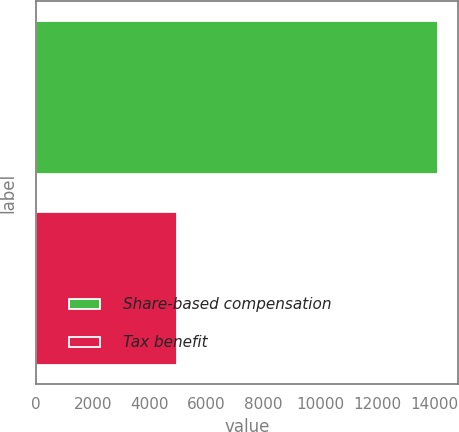Convert chart. <chart><loc_0><loc_0><loc_500><loc_500><bar_chart><fcel>Share-based compensation<fcel>Tax benefit<nl><fcel>14142<fcel>4950<nl></chart> 